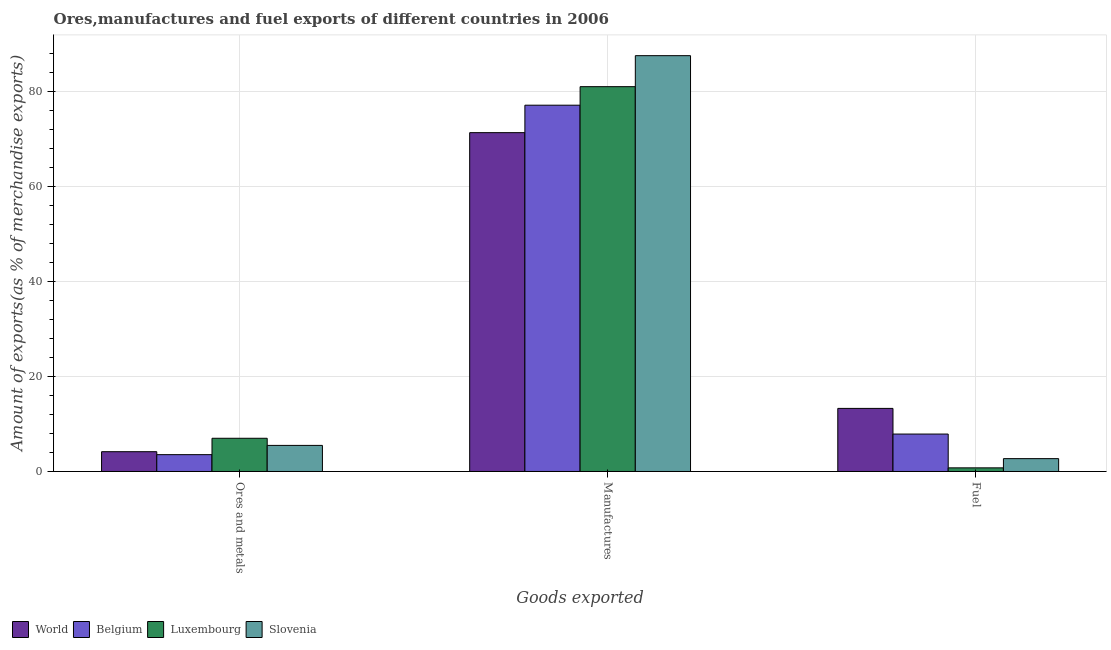How many different coloured bars are there?
Your response must be concise. 4. Are the number of bars per tick equal to the number of legend labels?
Give a very brief answer. Yes. Are the number of bars on each tick of the X-axis equal?
Ensure brevity in your answer.  Yes. How many bars are there on the 3rd tick from the right?
Offer a terse response. 4. What is the label of the 1st group of bars from the left?
Your answer should be compact. Ores and metals. What is the percentage of ores and metals exports in Slovenia?
Your response must be concise. 5.49. Across all countries, what is the maximum percentage of fuel exports?
Keep it short and to the point. 13.28. Across all countries, what is the minimum percentage of fuel exports?
Your answer should be compact. 0.76. In which country was the percentage of fuel exports maximum?
Your answer should be compact. World. In which country was the percentage of fuel exports minimum?
Make the answer very short. Luxembourg. What is the total percentage of fuel exports in the graph?
Give a very brief answer. 24.62. What is the difference between the percentage of manufactures exports in Luxembourg and that in Belgium?
Provide a succinct answer. 3.9. What is the difference between the percentage of manufactures exports in Belgium and the percentage of ores and metals exports in World?
Provide a succinct answer. 72.92. What is the average percentage of manufactures exports per country?
Provide a short and direct response. 79.23. What is the difference between the percentage of manufactures exports and percentage of fuel exports in Luxembourg?
Your answer should be very brief. 80.22. What is the ratio of the percentage of ores and metals exports in Slovenia to that in Luxembourg?
Your response must be concise. 0.79. Is the percentage of ores and metals exports in Luxembourg less than that in Slovenia?
Offer a terse response. No. What is the difference between the highest and the second highest percentage of manufactures exports?
Your answer should be very brief. 6.53. What is the difference between the highest and the lowest percentage of manufactures exports?
Your answer should be very brief. 16.2. What does the 3rd bar from the left in Manufactures represents?
Keep it short and to the point. Luxembourg. Are all the bars in the graph horizontal?
Provide a short and direct response. No. Does the graph contain grids?
Your answer should be compact. Yes. Where does the legend appear in the graph?
Offer a terse response. Bottom left. How are the legend labels stacked?
Offer a terse response. Horizontal. What is the title of the graph?
Give a very brief answer. Ores,manufactures and fuel exports of different countries in 2006. What is the label or title of the X-axis?
Provide a succinct answer. Goods exported. What is the label or title of the Y-axis?
Ensure brevity in your answer.  Amount of exports(as % of merchandise exports). What is the Amount of exports(as % of merchandise exports) in World in Ores and metals?
Your answer should be compact. 4.16. What is the Amount of exports(as % of merchandise exports) of Belgium in Ores and metals?
Give a very brief answer. 3.54. What is the Amount of exports(as % of merchandise exports) of Luxembourg in Ores and metals?
Offer a very short reply. 6.99. What is the Amount of exports(as % of merchandise exports) in Slovenia in Ores and metals?
Your answer should be very brief. 5.49. What is the Amount of exports(as % of merchandise exports) in World in Manufactures?
Your response must be concise. 71.31. What is the Amount of exports(as % of merchandise exports) in Belgium in Manufactures?
Give a very brief answer. 77.09. What is the Amount of exports(as % of merchandise exports) in Luxembourg in Manufactures?
Provide a short and direct response. 80.99. What is the Amount of exports(as % of merchandise exports) of Slovenia in Manufactures?
Give a very brief answer. 87.51. What is the Amount of exports(as % of merchandise exports) in World in Fuel?
Your response must be concise. 13.28. What is the Amount of exports(as % of merchandise exports) of Belgium in Fuel?
Offer a terse response. 7.88. What is the Amount of exports(as % of merchandise exports) in Luxembourg in Fuel?
Your response must be concise. 0.76. What is the Amount of exports(as % of merchandise exports) of Slovenia in Fuel?
Make the answer very short. 2.7. Across all Goods exported, what is the maximum Amount of exports(as % of merchandise exports) in World?
Provide a succinct answer. 71.31. Across all Goods exported, what is the maximum Amount of exports(as % of merchandise exports) in Belgium?
Give a very brief answer. 77.09. Across all Goods exported, what is the maximum Amount of exports(as % of merchandise exports) in Luxembourg?
Your answer should be very brief. 80.99. Across all Goods exported, what is the maximum Amount of exports(as % of merchandise exports) in Slovenia?
Provide a succinct answer. 87.51. Across all Goods exported, what is the minimum Amount of exports(as % of merchandise exports) of World?
Make the answer very short. 4.16. Across all Goods exported, what is the minimum Amount of exports(as % of merchandise exports) of Belgium?
Provide a short and direct response. 3.54. Across all Goods exported, what is the minimum Amount of exports(as % of merchandise exports) of Luxembourg?
Make the answer very short. 0.76. Across all Goods exported, what is the minimum Amount of exports(as % of merchandise exports) of Slovenia?
Ensure brevity in your answer.  2.7. What is the total Amount of exports(as % of merchandise exports) of World in the graph?
Provide a succinct answer. 88.75. What is the total Amount of exports(as % of merchandise exports) of Belgium in the graph?
Provide a short and direct response. 88.51. What is the total Amount of exports(as % of merchandise exports) in Luxembourg in the graph?
Provide a succinct answer. 88.74. What is the total Amount of exports(as % of merchandise exports) of Slovenia in the graph?
Ensure brevity in your answer.  95.71. What is the difference between the Amount of exports(as % of merchandise exports) in World in Ores and metals and that in Manufactures?
Provide a succinct answer. -67.15. What is the difference between the Amount of exports(as % of merchandise exports) in Belgium in Ores and metals and that in Manufactures?
Make the answer very short. -73.55. What is the difference between the Amount of exports(as % of merchandise exports) in Luxembourg in Ores and metals and that in Manufactures?
Offer a terse response. -74. What is the difference between the Amount of exports(as % of merchandise exports) in Slovenia in Ores and metals and that in Manufactures?
Give a very brief answer. -82.03. What is the difference between the Amount of exports(as % of merchandise exports) in World in Ores and metals and that in Fuel?
Give a very brief answer. -9.11. What is the difference between the Amount of exports(as % of merchandise exports) in Belgium in Ores and metals and that in Fuel?
Keep it short and to the point. -4.33. What is the difference between the Amount of exports(as % of merchandise exports) in Luxembourg in Ores and metals and that in Fuel?
Your answer should be compact. 6.22. What is the difference between the Amount of exports(as % of merchandise exports) of Slovenia in Ores and metals and that in Fuel?
Ensure brevity in your answer.  2.79. What is the difference between the Amount of exports(as % of merchandise exports) of World in Manufactures and that in Fuel?
Offer a very short reply. 58.03. What is the difference between the Amount of exports(as % of merchandise exports) of Belgium in Manufactures and that in Fuel?
Your answer should be compact. 69.21. What is the difference between the Amount of exports(as % of merchandise exports) in Luxembourg in Manufactures and that in Fuel?
Make the answer very short. 80.22. What is the difference between the Amount of exports(as % of merchandise exports) in Slovenia in Manufactures and that in Fuel?
Your answer should be very brief. 84.81. What is the difference between the Amount of exports(as % of merchandise exports) of World in Ores and metals and the Amount of exports(as % of merchandise exports) of Belgium in Manufactures?
Offer a very short reply. -72.92. What is the difference between the Amount of exports(as % of merchandise exports) of World in Ores and metals and the Amount of exports(as % of merchandise exports) of Luxembourg in Manufactures?
Provide a succinct answer. -76.82. What is the difference between the Amount of exports(as % of merchandise exports) in World in Ores and metals and the Amount of exports(as % of merchandise exports) in Slovenia in Manufactures?
Your answer should be very brief. -83.35. What is the difference between the Amount of exports(as % of merchandise exports) of Belgium in Ores and metals and the Amount of exports(as % of merchandise exports) of Luxembourg in Manufactures?
Give a very brief answer. -77.45. What is the difference between the Amount of exports(as % of merchandise exports) of Belgium in Ores and metals and the Amount of exports(as % of merchandise exports) of Slovenia in Manufactures?
Provide a succinct answer. -83.97. What is the difference between the Amount of exports(as % of merchandise exports) in Luxembourg in Ores and metals and the Amount of exports(as % of merchandise exports) in Slovenia in Manufactures?
Offer a terse response. -80.52. What is the difference between the Amount of exports(as % of merchandise exports) of World in Ores and metals and the Amount of exports(as % of merchandise exports) of Belgium in Fuel?
Your response must be concise. -3.71. What is the difference between the Amount of exports(as % of merchandise exports) in World in Ores and metals and the Amount of exports(as % of merchandise exports) in Luxembourg in Fuel?
Ensure brevity in your answer.  3.4. What is the difference between the Amount of exports(as % of merchandise exports) of World in Ores and metals and the Amount of exports(as % of merchandise exports) of Slovenia in Fuel?
Give a very brief answer. 1.46. What is the difference between the Amount of exports(as % of merchandise exports) of Belgium in Ores and metals and the Amount of exports(as % of merchandise exports) of Luxembourg in Fuel?
Offer a very short reply. 2.78. What is the difference between the Amount of exports(as % of merchandise exports) of Belgium in Ores and metals and the Amount of exports(as % of merchandise exports) of Slovenia in Fuel?
Make the answer very short. 0.84. What is the difference between the Amount of exports(as % of merchandise exports) of Luxembourg in Ores and metals and the Amount of exports(as % of merchandise exports) of Slovenia in Fuel?
Your response must be concise. 4.29. What is the difference between the Amount of exports(as % of merchandise exports) of World in Manufactures and the Amount of exports(as % of merchandise exports) of Belgium in Fuel?
Keep it short and to the point. 63.43. What is the difference between the Amount of exports(as % of merchandise exports) in World in Manufactures and the Amount of exports(as % of merchandise exports) in Luxembourg in Fuel?
Make the answer very short. 70.55. What is the difference between the Amount of exports(as % of merchandise exports) of World in Manufactures and the Amount of exports(as % of merchandise exports) of Slovenia in Fuel?
Your response must be concise. 68.61. What is the difference between the Amount of exports(as % of merchandise exports) in Belgium in Manufactures and the Amount of exports(as % of merchandise exports) in Luxembourg in Fuel?
Keep it short and to the point. 76.32. What is the difference between the Amount of exports(as % of merchandise exports) of Belgium in Manufactures and the Amount of exports(as % of merchandise exports) of Slovenia in Fuel?
Your answer should be compact. 74.38. What is the difference between the Amount of exports(as % of merchandise exports) in Luxembourg in Manufactures and the Amount of exports(as % of merchandise exports) in Slovenia in Fuel?
Offer a very short reply. 78.29. What is the average Amount of exports(as % of merchandise exports) in World per Goods exported?
Make the answer very short. 29.58. What is the average Amount of exports(as % of merchandise exports) of Belgium per Goods exported?
Provide a short and direct response. 29.5. What is the average Amount of exports(as % of merchandise exports) of Luxembourg per Goods exported?
Ensure brevity in your answer.  29.58. What is the average Amount of exports(as % of merchandise exports) in Slovenia per Goods exported?
Ensure brevity in your answer.  31.9. What is the difference between the Amount of exports(as % of merchandise exports) of World and Amount of exports(as % of merchandise exports) of Belgium in Ores and metals?
Your answer should be compact. 0.62. What is the difference between the Amount of exports(as % of merchandise exports) in World and Amount of exports(as % of merchandise exports) in Luxembourg in Ores and metals?
Your answer should be very brief. -2.82. What is the difference between the Amount of exports(as % of merchandise exports) of World and Amount of exports(as % of merchandise exports) of Slovenia in Ores and metals?
Your response must be concise. -1.32. What is the difference between the Amount of exports(as % of merchandise exports) of Belgium and Amount of exports(as % of merchandise exports) of Luxembourg in Ores and metals?
Ensure brevity in your answer.  -3.45. What is the difference between the Amount of exports(as % of merchandise exports) in Belgium and Amount of exports(as % of merchandise exports) in Slovenia in Ores and metals?
Ensure brevity in your answer.  -1.95. What is the difference between the Amount of exports(as % of merchandise exports) of Luxembourg and Amount of exports(as % of merchandise exports) of Slovenia in Ores and metals?
Ensure brevity in your answer.  1.5. What is the difference between the Amount of exports(as % of merchandise exports) of World and Amount of exports(as % of merchandise exports) of Belgium in Manufactures?
Make the answer very short. -5.78. What is the difference between the Amount of exports(as % of merchandise exports) in World and Amount of exports(as % of merchandise exports) in Luxembourg in Manufactures?
Your response must be concise. -9.68. What is the difference between the Amount of exports(as % of merchandise exports) of World and Amount of exports(as % of merchandise exports) of Slovenia in Manufactures?
Your answer should be compact. -16.2. What is the difference between the Amount of exports(as % of merchandise exports) of Belgium and Amount of exports(as % of merchandise exports) of Luxembourg in Manufactures?
Offer a terse response. -3.9. What is the difference between the Amount of exports(as % of merchandise exports) in Belgium and Amount of exports(as % of merchandise exports) in Slovenia in Manufactures?
Your answer should be compact. -10.43. What is the difference between the Amount of exports(as % of merchandise exports) of Luxembourg and Amount of exports(as % of merchandise exports) of Slovenia in Manufactures?
Provide a short and direct response. -6.53. What is the difference between the Amount of exports(as % of merchandise exports) in World and Amount of exports(as % of merchandise exports) in Belgium in Fuel?
Provide a succinct answer. 5.4. What is the difference between the Amount of exports(as % of merchandise exports) of World and Amount of exports(as % of merchandise exports) of Luxembourg in Fuel?
Offer a very short reply. 12.51. What is the difference between the Amount of exports(as % of merchandise exports) in World and Amount of exports(as % of merchandise exports) in Slovenia in Fuel?
Give a very brief answer. 10.57. What is the difference between the Amount of exports(as % of merchandise exports) of Belgium and Amount of exports(as % of merchandise exports) of Luxembourg in Fuel?
Your answer should be compact. 7.11. What is the difference between the Amount of exports(as % of merchandise exports) of Belgium and Amount of exports(as % of merchandise exports) of Slovenia in Fuel?
Provide a short and direct response. 5.17. What is the difference between the Amount of exports(as % of merchandise exports) of Luxembourg and Amount of exports(as % of merchandise exports) of Slovenia in Fuel?
Keep it short and to the point. -1.94. What is the ratio of the Amount of exports(as % of merchandise exports) in World in Ores and metals to that in Manufactures?
Your answer should be very brief. 0.06. What is the ratio of the Amount of exports(as % of merchandise exports) in Belgium in Ores and metals to that in Manufactures?
Offer a terse response. 0.05. What is the ratio of the Amount of exports(as % of merchandise exports) in Luxembourg in Ores and metals to that in Manufactures?
Your answer should be compact. 0.09. What is the ratio of the Amount of exports(as % of merchandise exports) of Slovenia in Ores and metals to that in Manufactures?
Your answer should be very brief. 0.06. What is the ratio of the Amount of exports(as % of merchandise exports) of World in Ores and metals to that in Fuel?
Your response must be concise. 0.31. What is the ratio of the Amount of exports(as % of merchandise exports) of Belgium in Ores and metals to that in Fuel?
Offer a terse response. 0.45. What is the ratio of the Amount of exports(as % of merchandise exports) of Luxembourg in Ores and metals to that in Fuel?
Ensure brevity in your answer.  9.15. What is the ratio of the Amount of exports(as % of merchandise exports) of Slovenia in Ores and metals to that in Fuel?
Your response must be concise. 2.03. What is the ratio of the Amount of exports(as % of merchandise exports) of World in Manufactures to that in Fuel?
Provide a short and direct response. 5.37. What is the ratio of the Amount of exports(as % of merchandise exports) in Belgium in Manufactures to that in Fuel?
Offer a very short reply. 9.79. What is the ratio of the Amount of exports(as % of merchandise exports) of Luxembourg in Manufactures to that in Fuel?
Provide a succinct answer. 106. What is the ratio of the Amount of exports(as % of merchandise exports) in Slovenia in Manufactures to that in Fuel?
Offer a terse response. 32.37. What is the difference between the highest and the second highest Amount of exports(as % of merchandise exports) of World?
Ensure brevity in your answer.  58.03. What is the difference between the highest and the second highest Amount of exports(as % of merchandise exports) in Belgium?
Offer a terse response. 69.21. What is the difference between the highest and the second highest Amount of exports(as % of merchandise exports) of Luxembourg?
Your response must be concise. 74. What is the difference between the highest and the second highest Amount of exports(as % of merchandise exports) in Slovenia?
Your answer should be very brief. 82.03. What is the difference between the highest and the lowest Amount of exports(as % of merchandise exports) in World?
Your response must be concise. 67.15. What is the difference between the highest and the lowest Amount of exports(as % of merchandise exports) in Belgium?
Your answer should be very brief. 73.55. What is the difference between the highest and the lowest Amount of exports(as % of merchandise exports) of Luxembourg?
Give a very brief answer. 80.22. What is the difference between the highest and the lowest Amount of exports(as % of merchandise exports) of Slovenia?
Keep it short and to the point. 84.81. 